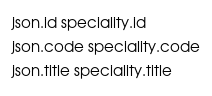Convert code to text. <code><loc_0><loc_0><loc_500><loc_500><_Ruby_>json.id speciality.id
json.code speciality.code
json.title speciality.title
</code> 